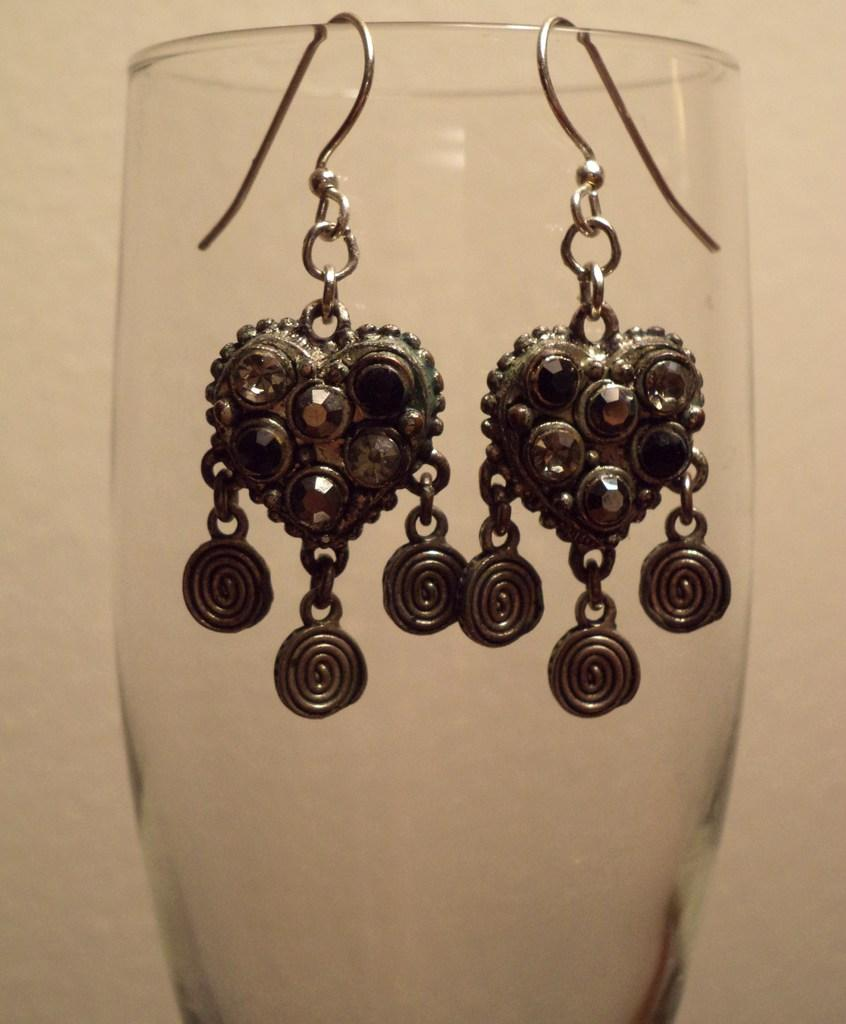What is the main object in the center of the image? There is a glass in the center of the image. What is placed on the glass? A pair of earrings is visible on the glass. What can be seen in the background of the image? There is a wall in the background of the image. How does the sand feel on the user's sense of touch in the image? There is no sand present in the image, so it cannot be felt or experienced in the image. 